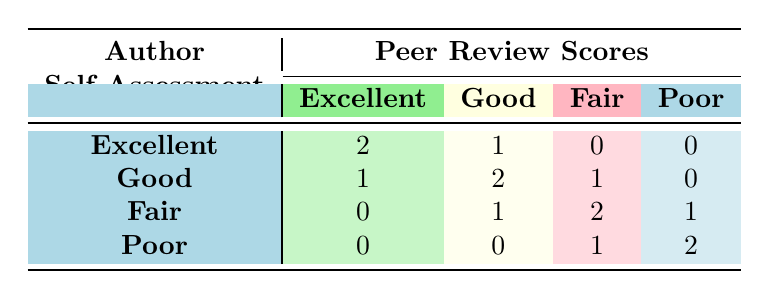What is the total number of authors who assessed themselves as 'Excellent'? From the table, we can see that there are two entries under the 'Excellent' category in the self-assessment row. These authors are John Smith and James Wilson. Hence, the total number of authors who assessed themselves as 'Excellent' is 2.
Answer: 2 How many authors received a 'Poor' peer review score? Looking under the 'Poor' column in the peer review scores, we see that there are 2 authors who received a 'Poor' score: Ahmed Khan and Fatima Patel. Therefore, the total number of authors with a 'Poor' score is 2.
Answer: 2 What is the difference between the number of authors who self-assessed as 'Good' and those who were rated 'Good' in peer reviews? There are 2 authors who self-assessed as 'Good' (Maria Garcia and Emily Johnson). For the peer review scores, there are also 2 authors rated as 'Good' (James Wilson and Maria Garcia). The difference between 2 and 2 is 0.
Answer: 0 Did any authors self-assess as 'Poor' and receive an 'Excellent' in peer reviews? Looking at the table, we see that there are no authors who self-assessed as 'Poor' (only Ahmed Khan and Fatima Patel) and received an 'Excellent' peer review score. Thus, the answer is no.
Answer: No Which self-assessment category has the highest number of agreements in peer review scores? By examining the confusion matrix, the 'Excellent' self-assessment category shows the highest agreement with peer review scores, where 2 authors self-assessed as 'Excellent' and received the same rating in peer reviews.
Answer: Excellent What is the total number of peer review scores that correspond to authors who self-assessed as 'Fair'? There are 4 scores corresponding to the authors who self-assessed as 'Fair': 1 (Good), 2 (Fair), and 1 (Poor). Summing these gives us 4 scores in total for authors with a 'Fair' self-assessment.
Answer: 4 How many authors received an 'Excellent' peer review score compared to those who self-assessed as 'Poor'? There are 2 authors who received an 'Excellent' score (John Smith and Emily Johnson) and 2 authors who self-assessed as 'Poor' (Ahmed Khan and Fatima Patel). Both categories have the same number, which is 2.
Answer: 2 Is it true that no authors self-assessed as 'Fair' received a 'Poor' in their peer review? Upon examining the 'Fair' self-assessment row, we see there is 1 author (Fatima Patel) who received a 'Poor' rating in peer review. Therefore, the statement is false.
Answer: False Which self-assessment category has the lowest number of ratings in peer reviews? The 'Poor' self-assessment category has the lowest number of ratings in peer reviews with 0 for 'Excellent', 0 for 'Good', 1 for 'Fair', and 2 for 'Poor', totaling 3 ratings.
Answer: Poor 